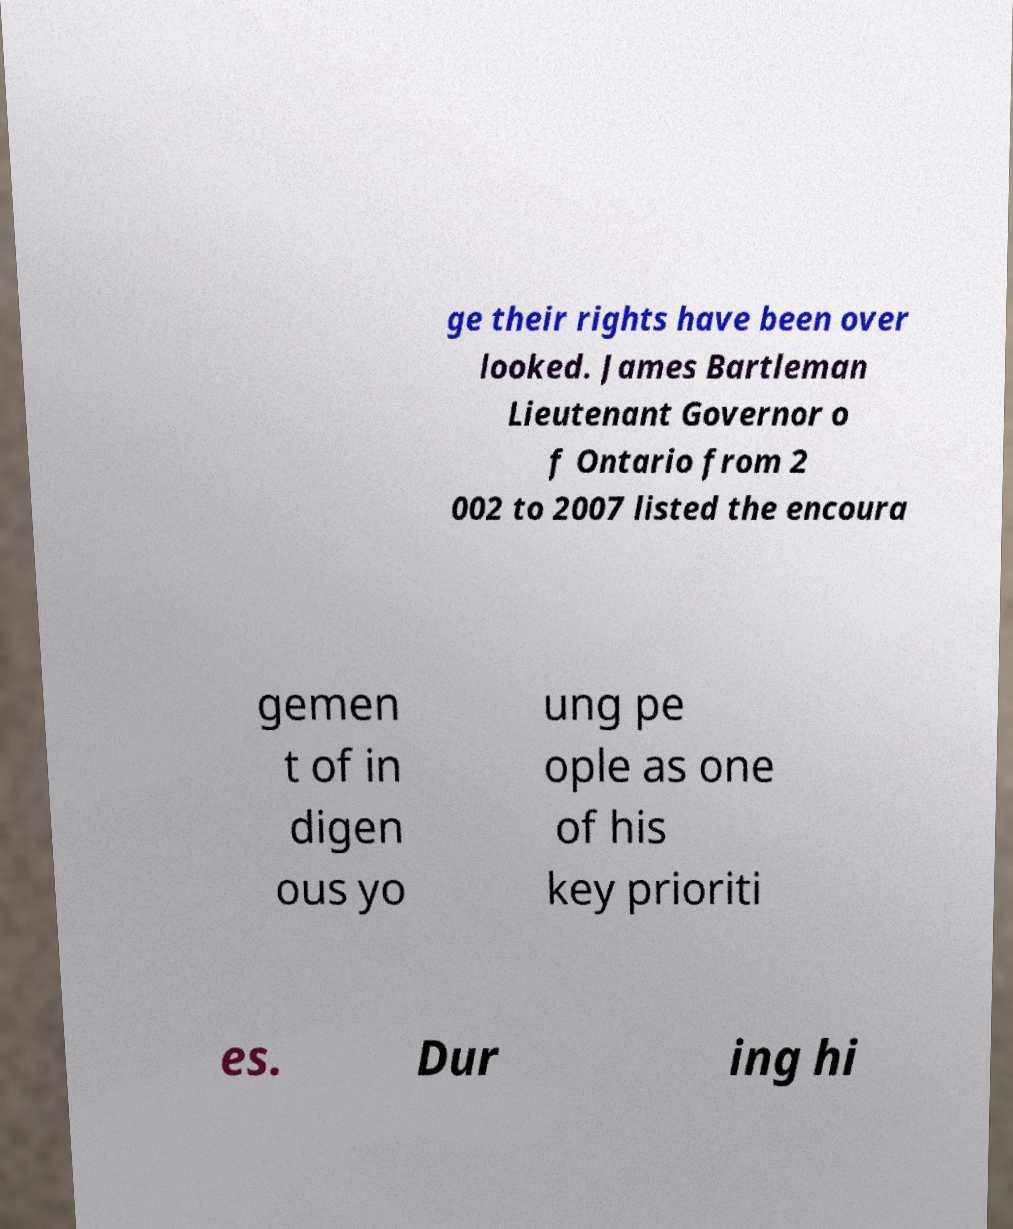I need the written content from this picture converted into text. Can you do that? ge their rights have been over looked. James Bartleman Lieutenant Governor o f Ontario from 2 002 to 2007 listed the encoura gemen t of in digen ous yo ung pe ople as one of his key prioriti es. Dur ing hi 